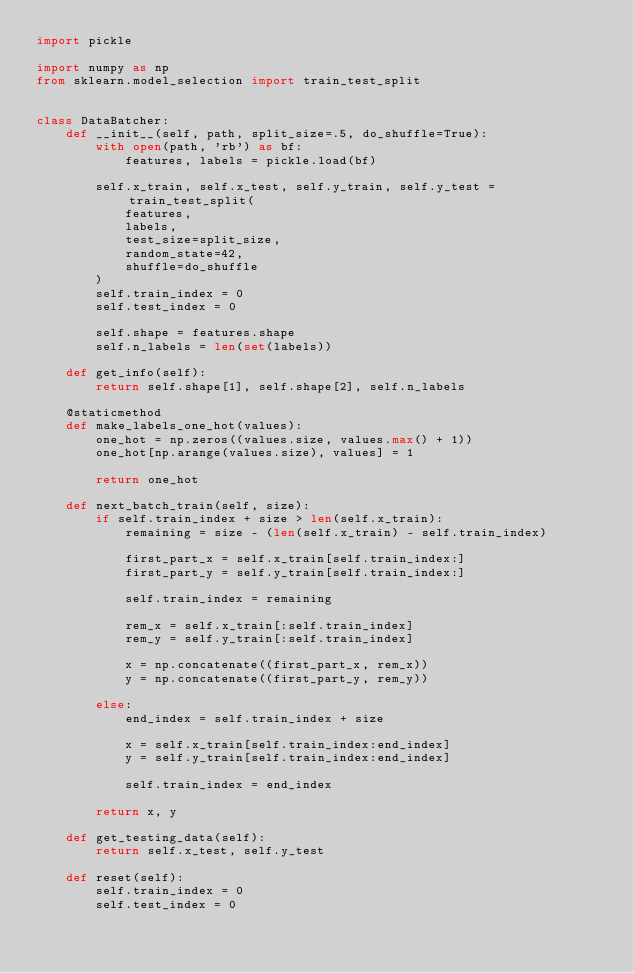Convert code to text. <code><loc_0><loc_0><loc_500><loc_500><_Python_>import pickle

import numpy as np
from sklearn.model_selection import train_test_split


class DataBatcher:
    def __init__(self, path, split_size=.5, do_shuffle=True):
        with open(path, 'rb') as bf:
            features, labels = pickle.load(bf)

        self.x_train, self.x_test, self.y_train, self.y_test = train_test_split(
            features,
            labels,
            test_size=split_size,
            random_state=42,
            shuffle=do_shuffle
        )
        self.train_index = 0
        self.test_index = 0

        self.shape = features.shape
        self.n_labels = len(set(labels))

    def get_info(self):
        return self.shape[1], self.shape[2], self.n_labels

    @staticmethod
    def make_labels_one_hot(values):
        one_hot = np.zeros((values.size, values.max() + 1))
        one_hot[np.arange(values.size), values] = 1

        return one_hot

    def next_batch_train(self, size):
        if self.train_index + size > len(self.x_train):
            remaining = size - (len(self.x_train) - self.train_index)

            first_part_x = self.x_train[self.train_index:]
            first_part_y = self.y_train[self.train_index:]

            self.train_index = remaining

            rem_x = self.x_train[:self.train_index]
            rem_y = self.y_train[:self.train_index]

            x = np.concatenate((first_part_x, rem_x))
            y = np.concatenate((first_part_y, rem_y))

        else:
            end_index = self.train_index + size

            x = self.x_train[self.train_index:end_index]
            y = self.y_train[self.train_index:end_index]

            self.train_index = end_index

        return x, y

    def get_testing_data(self):
        return self.x_test, self.y_test

    def reset(self):
        self.train_index = 0
        self.test_index = 0
</code> 